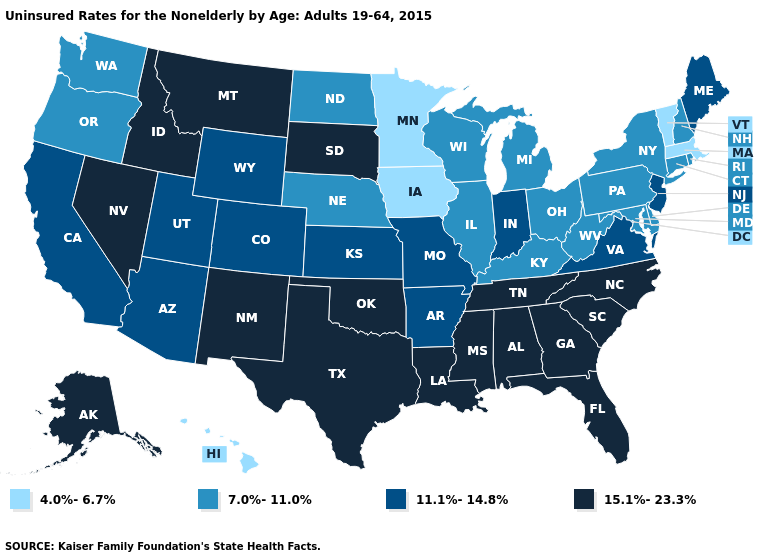Which states have the lowest value in the South?
Give a very brief answer. Delaware, Kentucky, Maryland, West Virginia. Does Oklahoma have the highest value in the USA?
Concise answer only. Yes. What is the lowest value in the USA?
Write a very short answer. 4.0%-6.7%. Does Idaho have the same value as New Mexico?
Short answer required. Yes. What is the value of Oklahoma?
Answer briefly. 15.1%-23.3%. What is the highest value in states that border Missouri?
Be succinct. 15.1%-23.3%. Name the states that have a value in the range 15.1%-23.3%?
Concise answer only. Alabama, Alaska, Florida, Georgia, Idaho, Louisiana, Mississippi, Montana, Nevada, New Mexico, North Carolina, Oklahoma, South Carolina, South Dakota, Tennessee, Texas. Name the states that have a value in the range 15.1%-23.3%?
Be succinct. Alabama, Alaska, Florida, Georgia, Idaho, Louisiana, Mississippi, Montana, Nevada, New Mexico, North Carolina, Oklahoma, South Carolina, South Dakota, Tennessee, Texas. What is the value of Virginia?
Keep it brief. 11.1%-14.8%. What is the value of California?
Quick response, please. 11.1%-14.8%. Name the states that have a value in the range 4.0%-6.7%?
Write a very short answer. Hawaii, Iowa, Massachusetts, Minnesota, Vermont. Does Florida have the same value as Oregon?
Answer briefly. No. Name the states that have a value in the range 15.1%-23.3%?
Give a very brief answer. Alabama, Alaska, Florida, Georgia, Idaho, Louisiana, Mississippi, Montana, Nevada, New Mexico, North Carolina, Oklahoma, South Carolina, South Dakota, Tennessee, Texas. Which states hav the highest value in the South?
Keep it brief. Alabama, Florida, Georgia, Louisiana, Mississippi, North Carolina, Oklahoma, South Carolina, Tennessee, Texas. Name the states that have a value in the range 15.1%-23.3%?
Be succinct. Alabama, Alaska, Florida, Georgia, Idaho, Louisiana, Mississippi, Montana, Nevada, New Mexico, North Carolina, Oklahoma, South Carolina, South Dakota, Tennessee, Texas. 